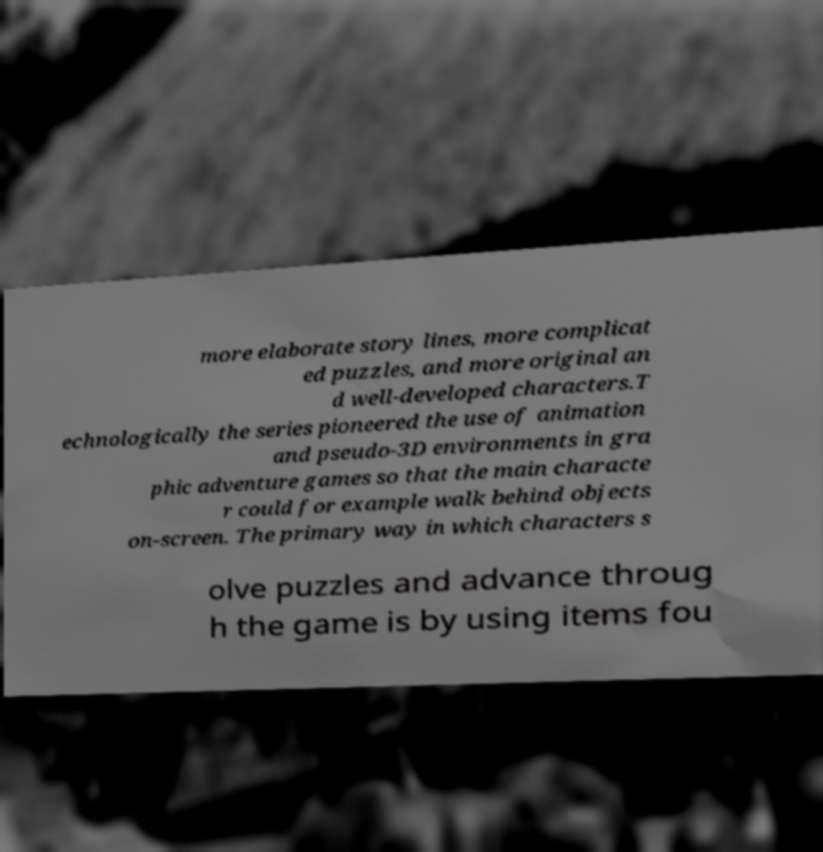Please read and relay the text visible in this image. What does it say? more elaborate story lines, more complicat ed puzzles, and more original an d well-developed characters.T echnologically the series pioneered the use of animation and pseudo-3D environments in gra phic adventure games so that the main characte r could for example walk behind objects on-screen. The primary way in which characters s olve puzzles and advance throug h the game is by using items fou 